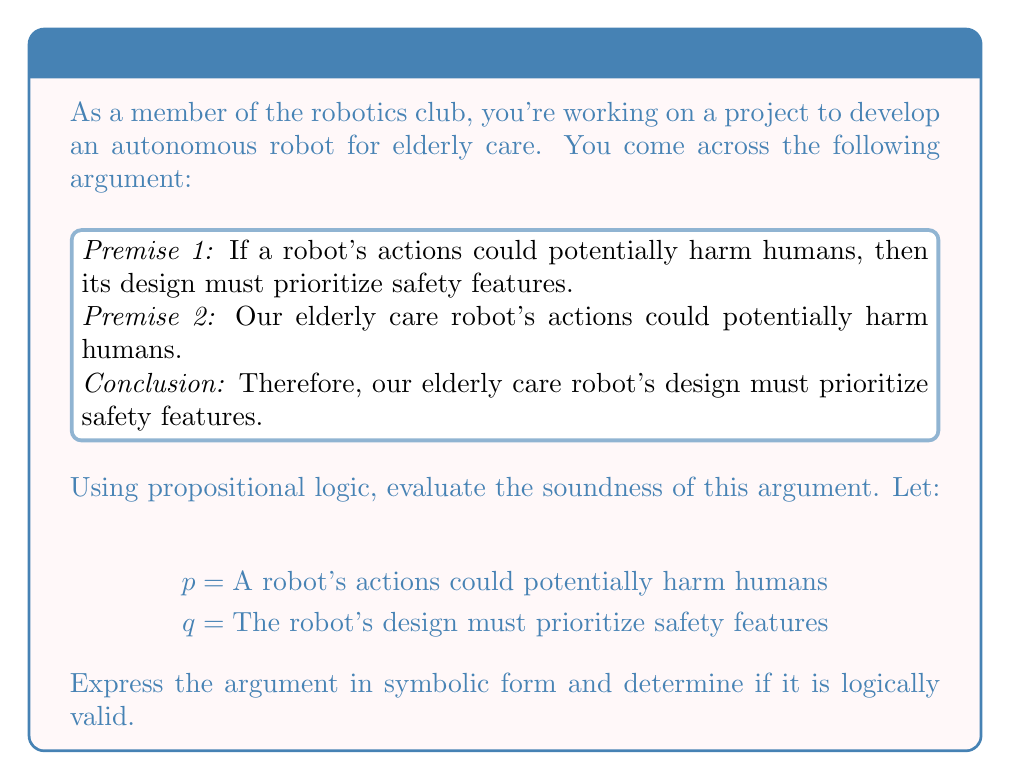Could you help me with this problem? Let's approach this step-by-step:

1) First, we need to translate the argument into symbolic form:

   Premise 1: $p \rightarrow q$
   Premise 2: $p$
   Conclusion: $q$

2) This form of argument is known as Modus Ponens, which has the structure:
   
   $$\frac{p \rightarrow q, p}{q}$$

3) To evaluate the validity of this argument, we can use a truth table:

   $$\begin{array}{|c|c|c|c|}
   \hline
   p & q & p \rightarrow q & (p \rightarrow q) \land p \rightarrow q \\
   \hline
   T & T & T & T \\
   T & F & F & T \\
   F & T & T & T \\
   F & F & T & T \\
   \hline
   \end{array}$$

4) The last column of the truth table represents the validity of the argument. If it's always true (T), the argument is valid.

5) As we can see, the last column is always T, which means this argument is logically valid.

6) For an argument to be sound, it must be both valid and have true premises. We've established validity, so we need to consider the truth of the premises:

   Premise 1 is generally accepted in engineering ethics.
   Premise 2 is true given the nature of elderly care robots interacting with humans.

7) Since both premises are true and the argument is valid, we can conclude that the argument is sound.
Answer: The argument is sound. 